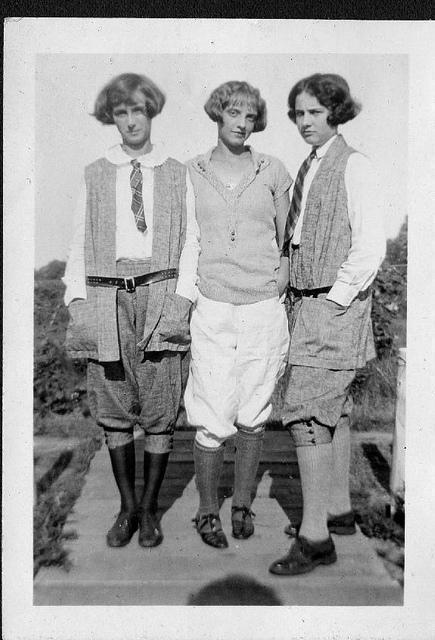How many people are here?
Give a very brief answer. 3. How many women are pictured?
Give a very brief answer. 3. How many baseball gloves are showing?
Give a very brief answer. 0. How many are looking at the camera?
Give a very brief answer. 3. How many people are sitting down?
Give a very brief answer. 0. How many men are there?
Give a very brief answer. 0. How many people are there?
Give a very brief answer. 3. How many trucks are crushing on the street?
Give a very brief answer. 0. 